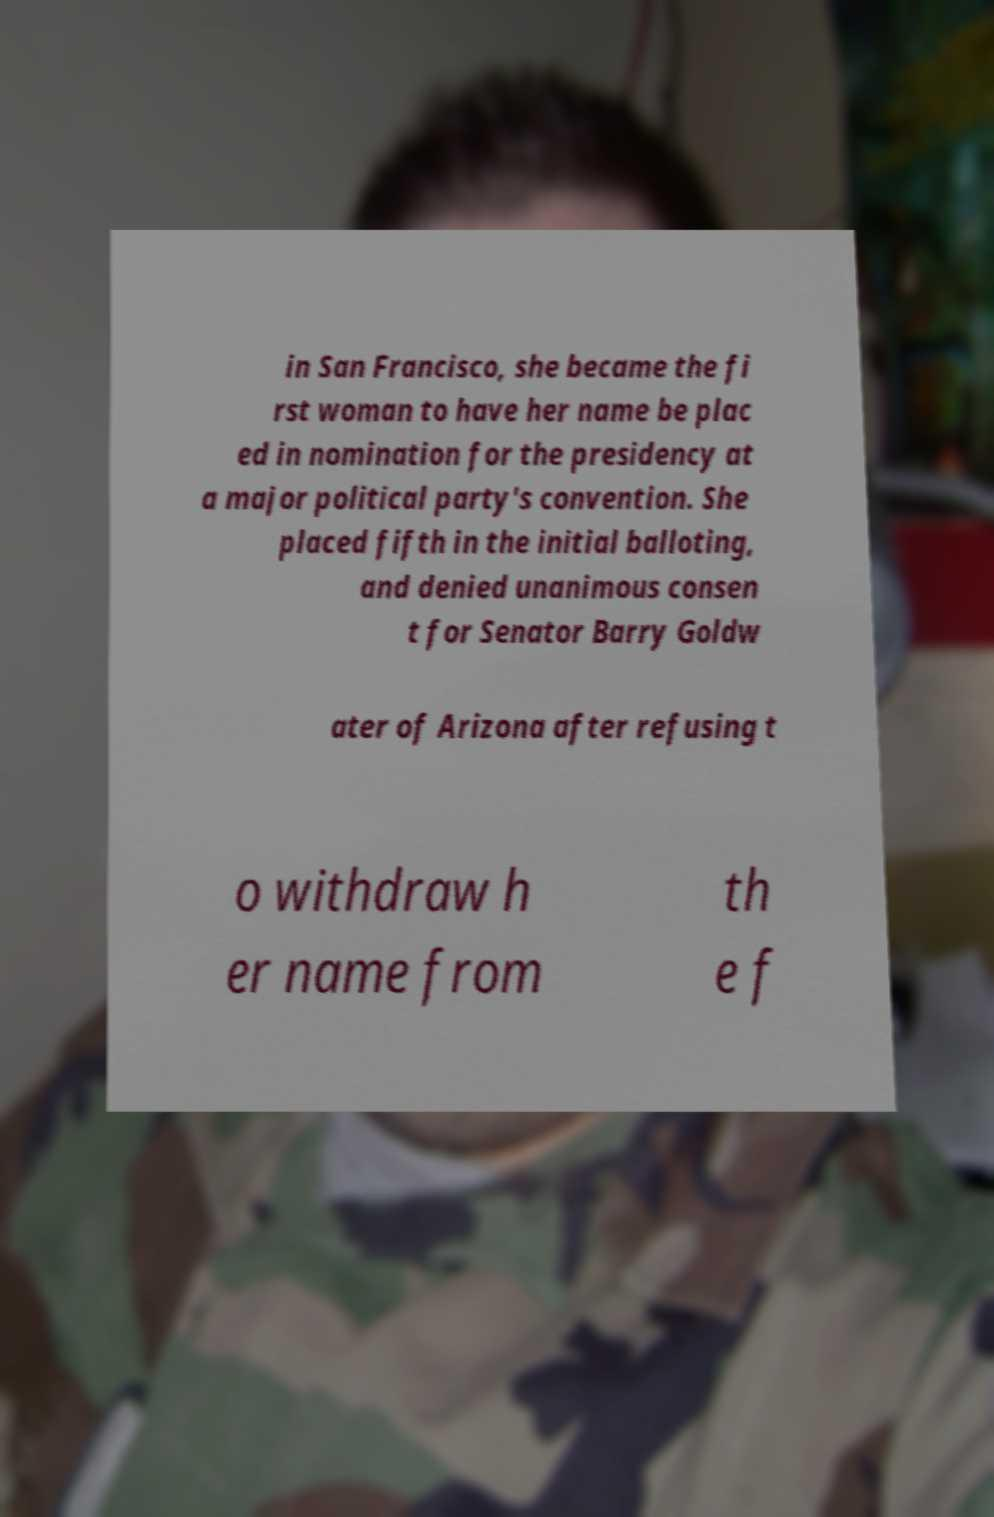Please read and relay the text visible in this image. What does it say? in San Francisco, she became the fi rst woman to have her name be plac ed in nomination for the presidency at a major political party's convention. She placed fifth in the initial balloting, and denied unanimous consen t for Senator Barry Goldw ater of Arizona after refusing t o withdraw h er name from th e f 